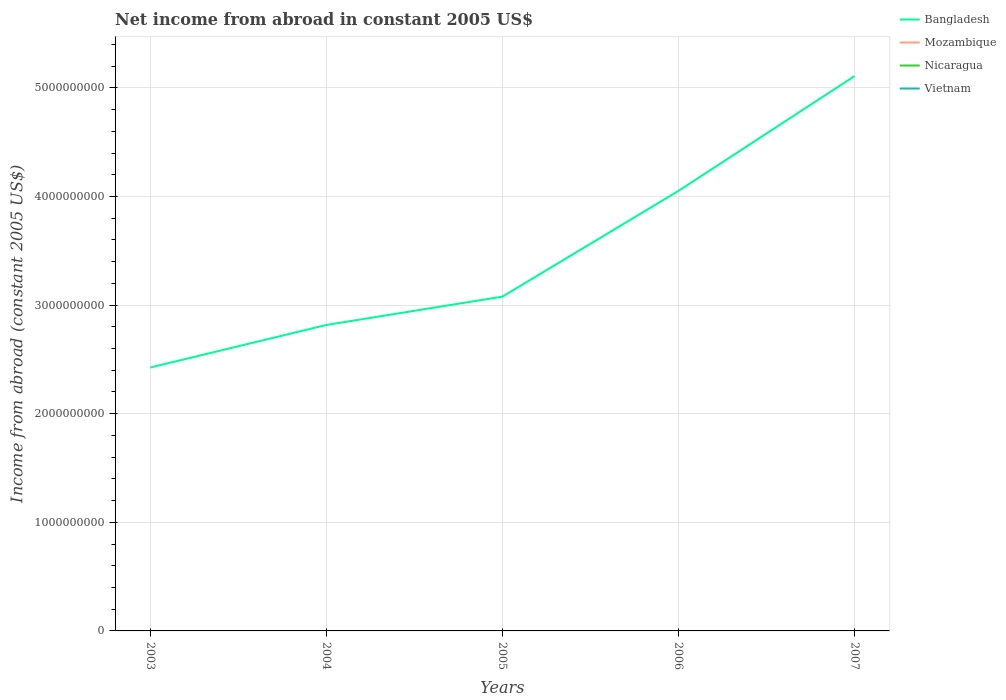Is the number of lines equal to the number of legend labels?
Your response must be concise. No. Across all years, what is the maximum net income from abroad in Bangladesh?
Ensure brevity in your answer.  2.43e+09. What is the total net income from abroad in Bangladesh in the graph?
Keep it short and to the point. -2.03e+09. What is the difference between the highest and the second highest net income from abroad in Bangladesh?
Keep it short and to the point. 2.68e+09. What is the difference between the highest and the lowest net income from abroad in Nicaragua?
Your answer should be compact. 0. Does the graph contain grids?
Offer a terse response. Yes. How many legend labels are there?
Your answer should be compact. 4. What is the title of the graph?
Offer a very short reply. Net income from abroad in constant 2005 US$. Does "Guinea" appear as one of the legend labels in the graph?
Ensure brevity in your answer.  No. What is the label or title of the Y-axis?
Keep it short and to the point. Income from abroad (constant 2005 US$). What is the Income from abroad (constant 2005 US$) of Bangladesh in 2003?
Offer a terse response. 2.43e+09. What is the Income from abroad (constant 2005 US$) in Mozambique in 2003?
Provide a succinct answer. 0. What is the Income from abroad (constant 2005 US$) in Nicaragua in 2003?
Provide a short and direct response. 0. What is the Income from abroad (constant 2005 US$) of Bangladesh in 2004?
Your response must be concise. 2.82e+09. What is the Income from abroad (constant 2005 US$) of Vietnam in 2004?
Ensure brevity in your answer.  0. What is the Income from abroad (constant 2005 US$) of Bangladesh in 2005?
Offer a terse response. 3.08e+09. What is the Income from abroad (constant 2005 US$) in Vietnam in 2005?
Your response must be concise. 0. What is the Income from abroad (constant 2005 US$) in Bangladesh in 2006?
Offer a terse response. 4.05e+09. What is the Income from abroad (constant 2005 US$) of Mozambique in 2006?
Offer a terse response. 0. What is the Income from abroad (constant 2005 US$) in Nicaragua in 2006?
Your response must be concise. 0. What is the Income from abroad (constant 2005 US$) of Bangladesh in 2007?
Your answer should be compact. 5.11e+09. What is the Income from abroad (constant 2005 US$) in Mozambique in 2007?
Ensure brevity in your answer.  0. Across all years, what is the maximum Income from abroad (constant 2005 US$) in Bangladesh?
Keep it short and to the point. 5.11e+09. Across all years, what is the minimum Income from abroad (constant 2005 US$) in Bangladesh?
Keep it short and to the point. 2.43e+09. What is the total Income from abroad (constant 2005 US$) in Bangladesh in the graph?
Make the answer very short. 1.75e+1. What is the difference between the Income from abroad (constant 2005 US$) in Bangladesh in 2003 and that in 2004?
Provide a succinct answer. -3.92e+08. What is the difference between the Income from abroad (constant 2005 US$) in Bangladesh in 2003 and that in 2005?
Give a very brief answer. -6.53e+08. What is the difference between the Income from abroad (constant 2005 US$) of Bangladesh in 2003 and that in 2006?
Provide a short and direct response. -1.63e+09. What is the difference between the Income from abroad (constant 2005 US$) in Bangladesh in 2003 and that in 2007?
Make the answer very short. -2.68e+09. What is the difference between the Income from abroad (constant 2005 US$) in Bangladesh in 2004 and that in 2005?
Keep it short and to the point. -2.61e+08. What is the difference between the Income from abroad (constant 2005 US$) in Bangladesh in 2004 and that in 2006?
Offer a very short reply. -1.23e+09. What is the difference between the Income from abroad (constant 2005 US$) of Bangladesh in 2004 and that in 2007?
Offer a very short reply. -2.29e+09. What is the difference between the Income from abroad (constant 2005 US$) in Bangladesh in 2005 and that in 2006?
Offer a terse response. -9.73e+08. What is the difference between the Income from abroad (constant 2005 US$) in Bangladesh in 2005 and that in 2007?
Ensure brevity in your answer.  -2.03e+09. What is the difference between the Income from abroad (constant 2005 US$) of Bangladesh in 2006 and that in 2007?
Your answer should be very brief. -1.06e+09. What is the average Income from abroad (constant 2005 US$) of Bangladesh per year?
Keep it short and to the point. 3.50e+09. What is the average Income from abroad (constant 2005 US$) in Mozambique per year?
Offer a terse response. 0. What is the average Income from abroad (constant 2005 US$) of Vietnam per year?
Offer a very short reply. 0. What is the ratio of the Income from abroad (constant 2005 US$) of Bangladesh in 2003 to that in 2004?
Your response must be concise. 0.86. What is the ratio of the Income from abroad (constant 2005 US$) of Bangladesh in 2003 to that in 2005?
Your answer should be compact. 0.79. What is the ratio of the Income from abroad (constant 2005 US$) in Bangladesh in 2003 to that in 2006?
Make the answer very short. 0.6. What is the ratio of the Income from abroad (constant 2005 US$) of Bangladesh in 2003 to that in 2007?
Ensure brevity in your answer.  0.47. What is the ratio of the Income from abroad (constant 2005 US$) of Bangladesh in 2004 to that in 2005?
Provide a short and direct response. 0.92. What is the ratio of the Income from abroad (constant 2005 US$) in Bangladesh in 2004 to that in 2006?
Ensure brevity in your answer.  0.7. What is the ratio of the Income from abroad (constant 2005 US$) of Bangladesh in 2004 to that in 2007?
Keep it short and to the point. 0.55. What is the ratio of the Income from abroad (constant 2005 US$) in Bangladesh in 2005 to that in 2006?
Offer a terse response. 0.76. What is the ratio of the Income from abroad (constant 2005 US$) of Bangladesh in 2005 to that in 2007?
Give a very brief answer. 0.6. What is the ratio of the Income from abroad (constant 2005 US$) of Bangladesh in 2006 to that in 2007?
Ensure brevity in your answer.  0.79. What is the difference between the highest and the second highest Income from abroad (constant 2005 US$) of Bangladesh?
Make the answer very short. 1.06e+09. What is the difference between the highest and the lowest Income from abroad (constant 2005 US$) of Bangladesh?
Your response must be concise. 2.68e+09. 